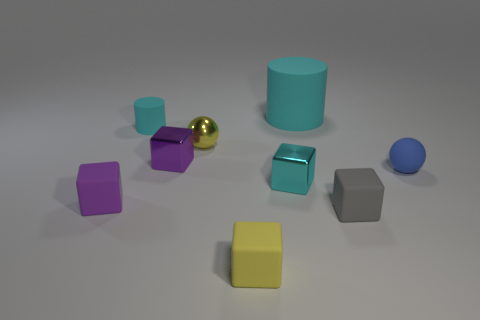There is a object that is both behind the small yellow sphere and left of the purple shiny thing; what shape is it?
Your response must be concise. Cylinder. What is the shape of the tiny yellow object behind the tiny purple block that is in front of the small blue object?
Your response must be concise. Sphere. Does the gray object have the same shape as the tiny blue thing?
Ensure brevity in your answer.  No. There is a tiny block that is the same color as the big cylinder; what is it made of?
Your answer should be very brief. Metal. Do the big rubber cylinder and the metal sphere have the same color?
Ensure brevity in your answer.  No. What number of spheres are in front of the tiny sphere that is behind the small purple object right of the small cylinder?
Keep it short and to the point. 1. There is a tiny purple object that is made of the same material as the tiny yellow ball; what shape is it?
Your answer should be compact. Cube. What is the material of the tiny ball that is left of the cylinder to the right of the small yellow object behind the small cyan metallic cube?
Provide a short and direct response. Metal. What number of things are either blue rubber objects in front of the large cyan cylinder or small yellow rubber spheres?
Ensure brevity in your answer.  1. How many other objects are there of the same shape as the tiny cyan shiny object?
Your answer should be compact. 4. 